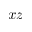<formula> <loc_0><loc_0><loc_500><loc_500>x z</formula> 